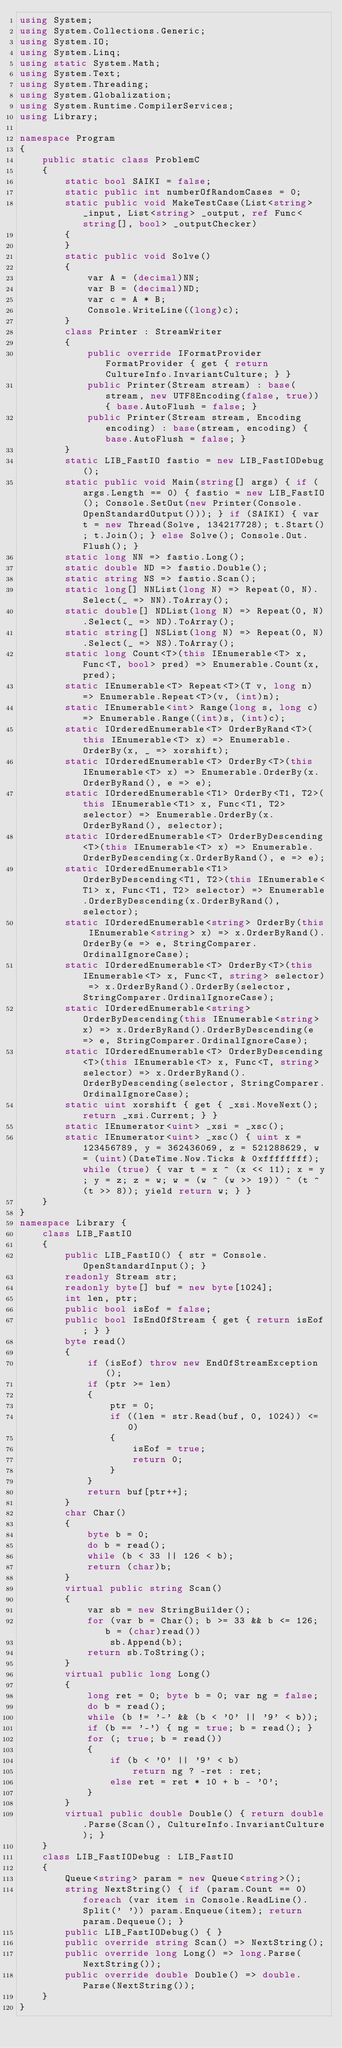<code> <loc_0><loc_0><loc_500><loc_500><_C#_>using System;
using System.Collections.Generic;
using System.IO;
using System.Linq;
using static System.Math;
using System.Text;
using System.Threading;
using System.Globalization;
using System.Runtime.CompilerServices;
using Library;

namespace Program
{
    public static class ProblemC
    {
        static bool SAIKI = false;
        static public int numberOfRandomCases = 0;
        static public void MakeTestCase(List<string> _input, List<string> _output, ref Func<string[], bool> _outputChecker)
        {
        }
        static public void Solve()
        {
            var A = (decimal)NN;
            var B = (decimal)ND;
            var c = A * B;
            Console.WriteLine((long)c);
        }
        class Printer : StreamWriter
        {
            public override IFormatProvider FormatProvider { get { return CultureInfo.InvariantCulture; } }
            public Printer(Stream stream) : base(stream, new UTF8Encoding(false, true)) { base.AutoFlush = false; }
            public Printer(Stream stream, Encoding encoding) : base(stream, encoding) { base.AutoFlush = false; }
        }
        static LIB_FastIO fastio = new LIB_FastIODebug();
        static public void Main(string[] args) { if (args.Length == 0) { fastio = new LIB_FastIO(); Console.SetOut(new Printer(Console.OpenStandardOutput())); } if (SAIKI) { var t = new Thread(Solve, 134217728); t.Start(); t.Join(); } else Solve(); Console.Out.Flush(); }
        static long NN => fastio.Long();
        static double ND => fastio.Double();
        static string NS => fastio.Scan();
        static long[] NNList(long N) => Repeat(0, N).Select(_ => NN).ToArray();
        static double[] NDList(long N) => Repeat(0, N).Select(_ => ND).ToArray();
        static string[] NSList(long N) => Repeat(0, N).Select(_ => NS).ToArray();
        static long Count<T>(this IEnumerable<T> x, Func<T, bool> pred) => Enumerable.Count(x, pred);
        static IEnumerable<T> Repeat<T>(T v, long n) => Enumerable.Repeat<T>(v, (int)n);
        static IEnumerable<int> Range(long s, long c) => Enumerable.Range((int)s, (int)c);
        static IOrderedEnumerable<T> OrderByRand<T>(this IEnumerable<T> x) => Enumerable.OrderBy(x, _ => xorshift);
        static IOrderedEnumerable<T> OrderBy<T>(this IEnumerable<T> x) => Enumerable.OrderBy(x.OrderByRand(), e => e);
        static IOrderedEnumerable<T1> OrderBy<T1, T2>(this IEnumerable<T1> x, Func<T1, T2> selector) => Enumerable.OrderBy(x.OrderByRand(), selector);
        static IOrderedEnumerable<T> OrderByDescending<T>(this IEnumerable<T> x) => Enumerable.OrderByDescending(x.OrderByRand(), e => e);
        static IOrderedEnumerable<T1> OrderByDescending<T1, T2>(this IEnumerable<T1> x, Func<T1, T2> selector) => Enumerable.OrderByDescending(x.OrderByRand(), selector);
        static IOrderedEnumerable<string> OrderBy(this IEnumerable<string> x) => x.OrderByRand().OrderBy(e => e, StringComparer.OrdinalIgnoreCase);
        static IOrderedEnumerable<T> OrderBy<T>(this IEnumerable<T> x, Func<T, string> selector) => x.OrderByRand().OrderBy(selector, StringComparer.OrdinalIgnoreCase);
        static IOrderedEnumerable<string> OrderByDescending(this IEnumerable<string> x) => x.OrderByRand().OrderByDescending(e => e, StringComparer.OrdinalIgnoreCase);
        static IOrderedEnumerable<T> OrderByDescending<T>(this IEnumerable<T> x, Func<T, string> selector) => x.OrderByRand().OrderByDescending(selector, StringComparer.OrdinalIgnoreCase);
        static uint xorshift { get { _xsi.MoveNext(); return _xsi.Current; } }
        static IEnumerator<uint> _xsi = _xsc();
        static IEnumerator<uint> _xsc() { uint x = 123456789, y = 362436069, z = 521288629, w = (uint)(DateTime.Now.Ticks & 0xffffffff); while (true) { var t = x ^ (x << 11); x = y; y = z; z = w; w = (w ^ (w >> 19)) ^ (t ^ (t >> 8)); yield return w; } }
    }
}
namespace Library {
    class LIB_FastIO
    {
        public LIB_FastIO() { str = Console.OpenStandardInput(); }
        readonly Stream str;
        readonly byte[] buf = new byte[1024];
        int len, ptr;
        public bool isEof = false;
        public bool IsEndOfStream { get { return isEof; } }
        byte read()
        {
            if (isEof) throw new EndOfStreamException();
            if (ptr >= len)
            {
                ptr = 0;
                if ((len = str.Read(buf, 0, 1024)) <= 0)
                {
                    isEof = true;
                    return 0;
                }
            }
            return buf[ptr++];
        }
        char Char()
        {
            byte b = 0;
            do b = read();
            while (b < 33 || 126 < b);
            return (char)b;
        }
        virtual public string Scan()
        {
            var sb = new StringBuilder();
            for (var b = Char(); b >= 33 && b <= 126; b = (char)read())
                sb.Append(b);
            return sb.ToString();
        }
        virtual public long Long()
        {
            long ret = 0; byte b = 0; var ng = false;
            do b = read();
            while (b != '-' && (b < '0' || '9' < b));
            if (b == '-') { ng = true; b = read(); }
            for (; true; b = read())
            {
                if (b < '0' || '9' < b)
                    return ng ? -ret : ret;
                else ret = ret * 10 + b - '0';
            }
        }
        virtual public double Double() { return double.Parse(Scan(), CultureInfo.InvariantCulture); }
    }
    class LIB_FastIODebug : LIB_FastIO
    {
        Queue<string> param = new Queue<string>();
        string NextString() { if (param.Count == 0) foreach (var item in Console.ReadLine().Split(' ')) param.Enqueue(item); return param.Dequeue(); }
        public LIB_FastIODebug() { }
        public override string Scan() => NextString();
        public override long Long() => long.Parse(NextString());
        public override double Double() => double.Parse(NextString());
    }
}
</code> 